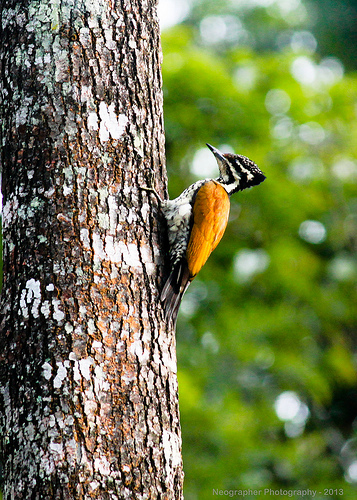Please provide a short description for this region: [0.46, 0.37, 0.54, 0.49]. This specific area is filled with a cluster of white feathers, which form a critical part of the bird's insulative and camouflage strategies. 